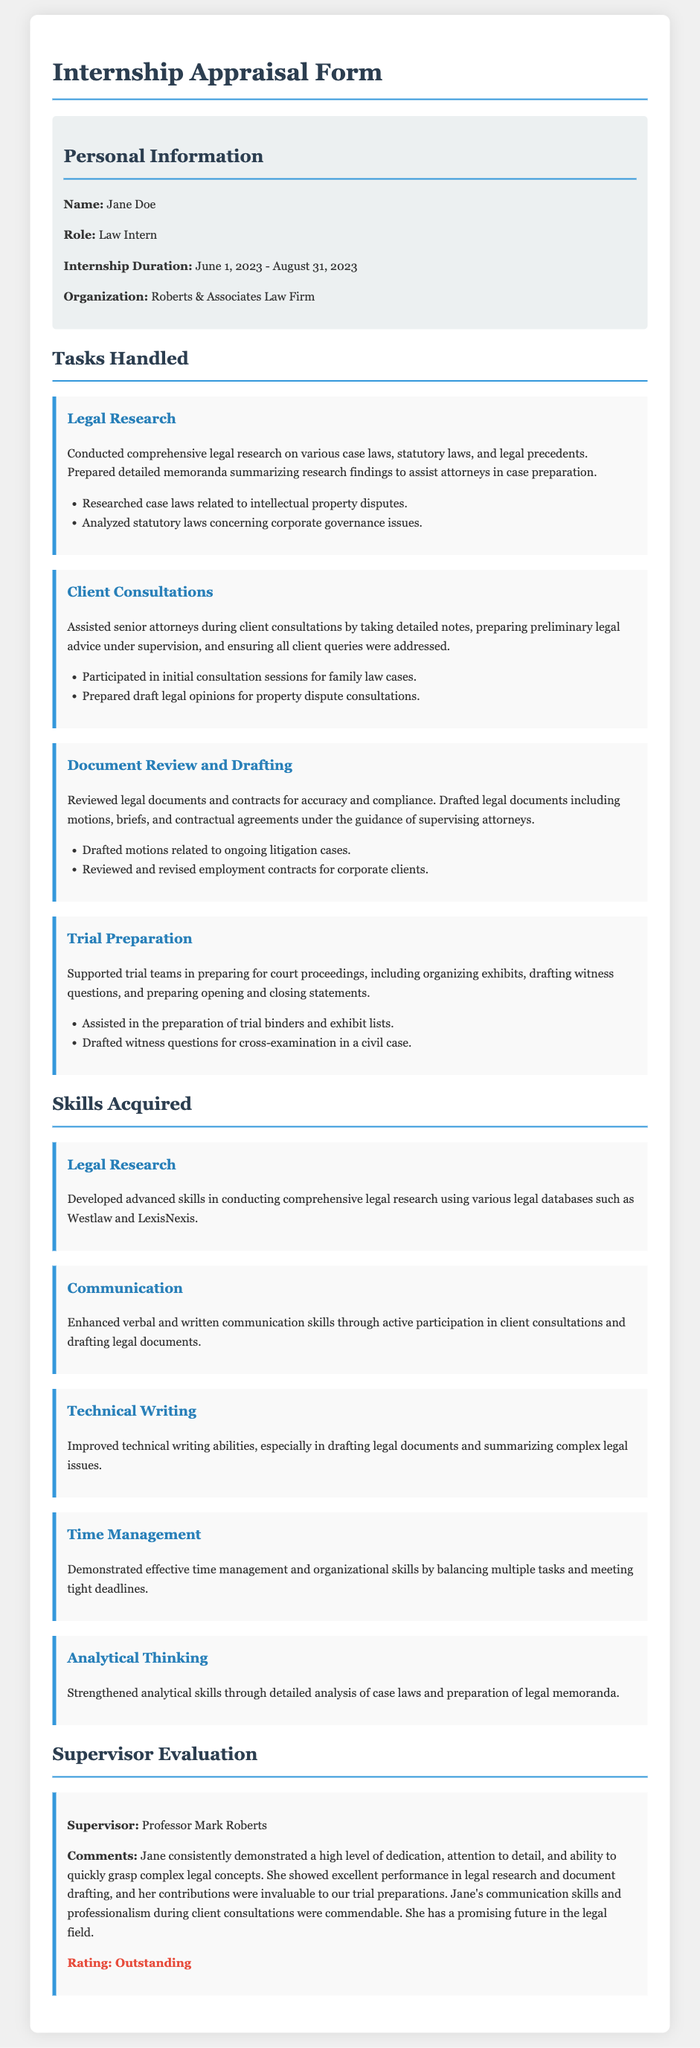What is the name of the intern? The intern's name is provided in the personal information section of the document.
Answer: Jane Doe What organization did the intern work for? The organization is mentioned in the personal information section of the document.
Answer: Roberts & Associates Law Firm What was the internship duration? The duration of the internship is listed in the personal information section of the document.
Answer: June 1, 2023 - August 31, 2023 Which skill was developed in legal research? The skills section includes various skills acquired during the internship, one related to legal research.
Answer: Advanced skills in conducting comprehensive legal research What rating did the supervisor give? The rating can be found in the supervisor evaluation section of the document.
Answer: Outstanding What type of cases did the intern participate in during client consultations? The tasks handled section includes examples of types of cases the intern worked on.
Answer: Family law cases Who was the supervisor of the intern? The supervisor's name is listed in the supervisor evaluation section of the document.
Answer: Professor Mark Roberts What was one of the tasks under "Trial Preparation"? The tasks handled section outlines specific tasks the intern performed.
Answer: Organizing exhibits Describe the level of dedication shown by the intern according to the supervisor. The supervisor's comments provide an evaluation of the intern's performance.
Answer: High level of dedication 